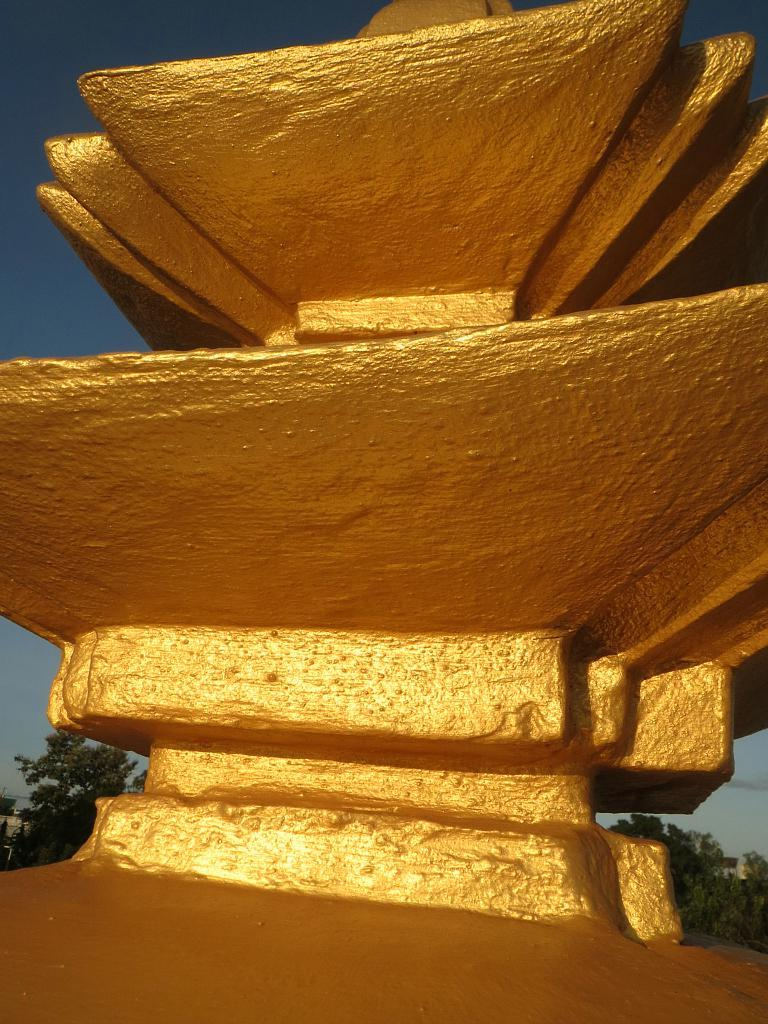What is the main subject in the foreground of the image? There is a golden structure in the foreground of the image. What can be seen in the background of the image? There are trees and the sky visible in the background of the image. How does the elbow contribute to the design of the golden structure in the image? There is no mention of an elbow in the image, and it does not appear to be a part of the golden structure's design. 